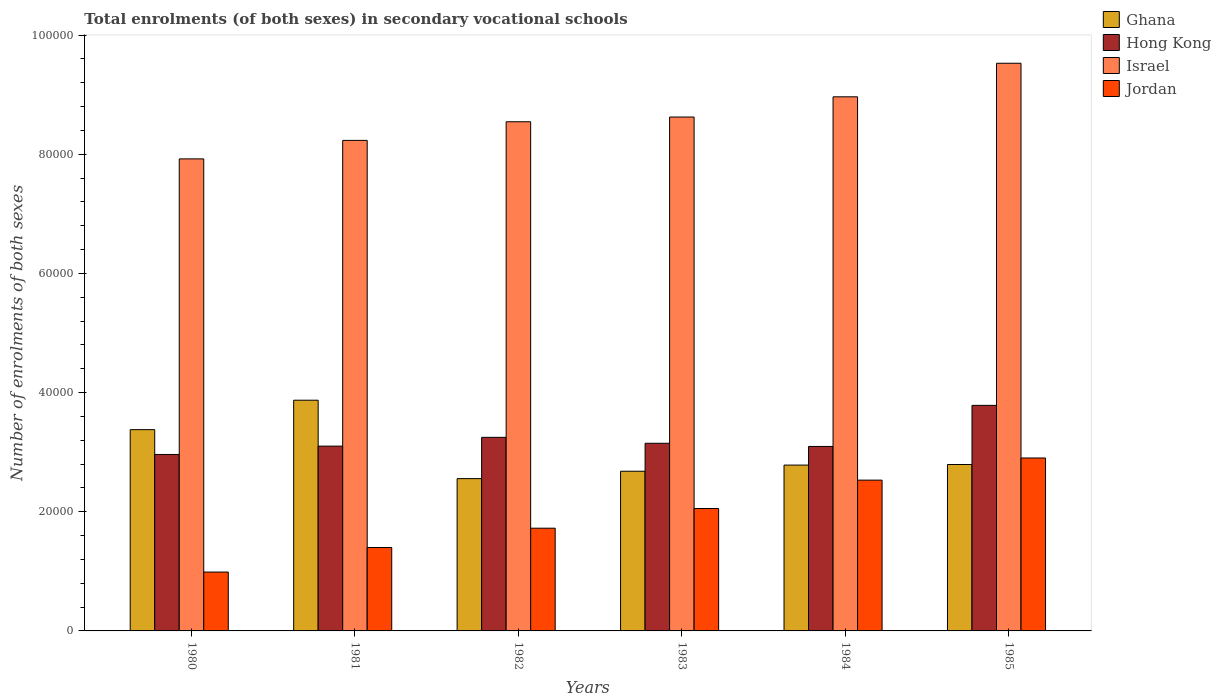How many different coloured bars are there?
Make the answer very short. 4. Are the number of bars per tick equal to the number of legend labels?
Provide a short and direct response. Yes. Are the number of bars on each tick of the X-axis equal?
Offer a terse response. Yes. How many bars are there on the 6th tick from the left?
Your answer should be very brief. 4. In how many cases, is the number of bars for a given year not equal to the number of legend labels?
Your answer should be compact. 0. What is the number of enrolments in secondary schools in Hong Kong in 1984?
Your answer should be compact. 3.10e+04. Across all years, what is the maximum number of enrolments in secondary schools in Ghana?
Offer a very short reply. 3.87e+04. Across all years, what is the minimum number of enrolments in secondary schools in Hong Kong?
Offer a very short reply. 2.96e+04. What is the total number of enrolments in secondary schools in Ghana in the graph?
Keep it short and to the point. 1.81e+05. What is the difference between the number of enrolments in secondary schools in Hong Kong in 1982 and the number of enrolments in secondary schools in Jordan in 1983?
Your response must be concise. 1.19e+04. What is the average number of enrolments in secondary schools in Hong Kong per year?
Your response must be concise. 3.22e+04. In the year 1980, what is the difference between the number of enrolments in secondary schools in Hong Kong and number of enrolments in secondary schools in Jordan?
Your response must be concise. 1.97e+04. What is the ratio of the number of enrolments in secondary schools in Jordan in 1980 to that in 1984?
Keep it short and to the point. 0.39. Is the difference between the number of enrolments in secondary schools in Hong Kong in 1981 and 1982 greater than the difference between the number of enrolments in secondary schools in Jordan in 1981 and 1982?
Provide a succinct answer. Yes. What is the difference between the highest and the second highest number of enrolments in secondary schools in Ghana?
Provide a succinct answer. 4941. What is the difference between the highest and the lowest number of enrolments in secondary schools in Jordan?
Your answer should be very brief. 1.91e+04. In how many years, is the number of enrolments in secondary schools in Hong Kong greater than the average number of enrolments in secondary schools in Hong Kong taken over all years?
Offer a very short reply. 2. Is the sum of the number of enrolments in secondary schools in Ghana in 1980 and 1982 greater than the maximum number of enrolments in secondary schools in Israel across all years?
Make the answer very short. No. What does the 3rd bar from the left in 1984 represents?
Your answer should be very brief. Israel. What does the 1st bar from the right in 1982 represents?
Your answer should be very brief. Jordan. How many bars are there?
Offer a terse response. 24. Are all the bars in the graph horizontal?
Offer a terse response. No. How many years are there in the graph?
Your answer should be very brief. 6. What is the difference between two consecutive major ticks on the Y-axis?
Ensure brevity in your answer.  2.00e+04. Are the values on the major ticks of Y-axis written in scientific E-notation?
Offer a very short reply. No. Does the graph contain grids?
Make the answer very short. No. How many legend labels are there?
Your response must be concise. 4. How are the legend labels stacked?
Provide a short and direct response. Vertical. What is the title of the graph?
Your answer should be very brief. Total enrolments (of both sexes) in secondary vocational schools. Does "Tunisia" appear as one of the legend labels in the graph?
Provide a short and direct response. No. What is the label or title of the Y-axis?
Your answer should be very brief. Number of enrolments of both sexes. What is the Number of enrolments of both sexes of Ghana in 1980?
Make the answer very short. 3.38e+04. What is the Number of enrolments of both sexes in Hong Kong in 1980?
Offer a very short reply. 2.96e+04. What is the Number of enrolments of both sexes of Israel in 1980?
Offer a terse response. 7.92e+04. What is the Number of enrolments of both sexes in Jordan in 1980?
Offer a terse response. 9880. What is the Number of enrolments of both sexes of Ghana in 1981?
Provide a short and direct response. 3.87e+04. What is the Number of enrolments of both sexes in Hong Kong in 1981?
Offer a very short reply. 3.10e+04. What is the Number of enrolments of both sexes in Israel in 1981?
Make the answer very short. 8.23e+04. What is the Number of enrolments of both sexes of Jordan in 1981?
Provide a short and direct response. 1.40e+04. What is the Number of enrolments of both sexes of Ghana in 1982?
Offer a very short reply. 2.56e+04. What is the Number of enrolments of both sexes of Hong Kong in 1982?
Offer a very short reply. 3.25e+04. What is the Number of enrolments of both sexes of Israel in 1982?
Give a very brief answer. 8.55e+04. What is the Number of enrolments of both sexes in Jordan in 1982?
Ensure brevity in your answer.  1.72e+04. What is the Number of enrolments of both sexes in Ghana in 1983?
Offer a very short reply. 2.68e+04. What is the Number of enrolments of both sexes in Hong Kong in 1983?
Your answer should be very brief. 3.15e+04. What is the Number of enrolments of both sexes of Israel in 1983?
Your answer should be very brief. 8.63e+04. What is the Number of enrolments of both sexes in Jordan in 1983?
Offer a very short reply. 2.05e+04. What is the Number of enrolments of both sexes in Ghana in 1984?
Offer a very short reply. 2.78e+04. What is the Number of enrolments of both sexes in Hong Kong in 1984?
Keep it short and to the point. 3.10e+04. What is the Number of enrolments of both sexes in Israel in 1984?
Provide a succinct answer. 8.96e+04. What is the Number of enrolments of both sexes in Jordan in 1984?
Provide a short and direct response. 2.53e+04. What is the Number of enrolments of both sexes in Ghana in 1985?
Your answer should be compact. 2.79e+04. What is the Number of enrolments of both sexes of Hong Kong in 1985?
Your answer should be compact. 3.79e+04. What is the Number of enrolments of both sexes in Israel in 1985?
Keep it short and to the point. 9.53e+04. What is the Number of enrolments of both sexes in Jordan in 1985?
Keep it short and to the point. 2.90e+04. Across all years, what is the maximum Number of enrolments of both sexes of Ghana?
Give a very brief answer. 3.87e+04. Across all years, what is the maximum Number of enrolments of both sexes in Hong Kong?
Your answer should be very brief. 3.79e+04. Across all years, what is the maximum Number of enrolments of both sexes in Israel?
Offer a very short reply. 9.53e+04. Across all years, what is the maximum Number of enrolments of both sexes in Jordan?
Offer a terse response. 2.90e+04. Across all years, what is the minimum Number of enrolments of both sexes of Ghana?
Your answer should be compact. 2.56e+04. Across all years, what is the minimum Number of enrolments of both sexes of Hong Kong?
Ensure brevity in your answer.  2.96e+04. Across all years, what is the minimum Number of enrolments of both sexes in Israel?
Give a very brief answer. 7.92e+04. Across all years, what is the minimum Number of enrolments of both sexes in Jordan?
Provide a succinct answer. 9880. What is the total Number of enrolments of both sexes of Ghana in the graph?
Provide a short and direct response. 1.81e+05. What is the total Number of enrolments of both sexes of Hong Kong in the graph?
Your answer should be compact. 1.93e+05. What is the total Number of enrolments of both sexes of Israel in the graph?
Ensure brevity in your answer.  5.18e+05. What is the total Number of enrolments of both sexes of Jordan in the graph?
Provide a succinct answer. 1.16e+05. What is the difference between the Number of enrolments of both sexes in Ghana in 1980 and that in 1981?
Your response must be concise. -4941. What is the difference between the Number of enrolments of both sexes of Hong Kong in 1980 and that in 1981?
Ensure brevity in your answer.  -1402. What is the difference between the Number of enrolments of both sexes of Israel in 1980 and that in 1981?
Offer a terse response. -3104. What is the difference between the Number of enrolments of both sexes in Jordan in 1980 and that in 1981?
Make the answer very short. -4121. What is the difference between the Number of enrolments of both sexes of Ghana in 1980 and that in 1982?
Your answer should be very brief. 8219. What is the difference between the Number of enrolments of both sexes of Hong Kong in 1980 and that in 1982?
Provide a short and direct response. -2875. What is the difference between the Number of enrolments of both sexes in Israel in 1980 and that in 1982?
Your answer should be compact. -6231. What is the difference between the Number of enrolments of both sexes in Jordan in 1980 and that in 1982?
Your response must be concise. -7362. What is the difference between the Number of enrolments of both sexes of Ghana in 1980 and that in 1983?
Your response must be concise. 6981. What is the difference between the Number of enrolments of both sexes of Hong Kong in 1980 and that in 1983?
Make the answer very short. -1877. What is the difference between the Number of enrolments of both sexes in Israel in 1980 and that in 1983?
Your answer should be compact. -7025. What is the difference between the Number of enrolments of both sexes of Jordan in 1980 and that in 1983?
Your answer should be compact. -1.07e+04. What is the difference between the Number of enrolments of both sexes of Ghana in 1980 and that in 1984?
Offer a terse response. 5948. What is the difference between the Number of enrolments of both sexes in Hong Kong in 1980 and that in 1984?
Give a very brief answer. -1347. What is the difference between the Number of enrolments of both sexes of Israel in 1980 and that in 1984?
Offer a very short reply. -1.04e+04. What is the difference between the Number of enrolments of both sexes in Jordan in 1980 and that in 1984?
Your answer should be compact. -1.54e+04. What is the difference between the Number of enrolments of both sexes in Ghana in 1980 and that in 1985?
Provide a short and direct response. 5850. What is the difference between the Number of enrolments of both sexes in Hong Kong in 1980 and that in 1985?
Keep it short and to the point. -8241. What is the difference between the Number of enrolments of both sexes in Israel in 1980 and that in 1985?
Offer a very short reply. -1.60e+04. What is the difference between the Number of enrolments of both sexes of Jordan in 1980 and that in 1985?
Provide a short and direct response. -1.91e+04. What is the difference between the Number of enrolments of both sexes in Ghana in 1981 and that in 1982?
Ensure brevity in your answer.  1.32e+04. What is the difference between the Number of enrolments of both sexes in Hong Kong in 1981 and that in 1982?
Provide a succinct answer. -1473. What is the difference between the Number of enrolments of both sexes of Israel in 1981 and that in 1982?
Provide a succinct answer. -3127. What is the difference between the Number of enrolments of both sexes of Jordan in 1981 and that in 1982?
Give a very brief answer. -3241. What is the difference between the Number of enrolments of both sexes of Ghana in 1981 and that in 1983?
Keep it short and to the point. 1.19e+04. What is the difference between the Number of enrolments of both sexes in Hong Kong in 1981 and that in 1983?
Ensure brevity in your answer.  -475. What is the difference between the Number of enrolments of both sexes of Israel in 1981 and that in 1983?
Offer a terse response. -3921. What is the difference between the Number of enrolments of both sexes of Jordan in 1981 and that in 1983?
Keep it short and to the point. -6548. What is the difference between the Number of enrolments of both sexes of Ghana in 1981 and that in 1984?
Keep it short and to the point. 1.09e+04. What is the difference between the Number of enrolments of both sexes in Hong Kong in 1981 and that in 1984?
Your answer should be very brief. 55. What is the difference between the Number of enrolments of both sexes of Israel in 1981 and that in 1984?
Give a very brief answer. -7314. What is the difference between the Number of enrolments of both sexes in Jordan in 1981 and that in 1984?
Give a very brief answer. -1.13e+04. What is the difference between the Number of enrolments of both sexes of Ghana in 1981 and that in 1985?
Provide a short and direct response. 1.08e+04. What is the difference between the Number of enrolments of both sexes in Hong Kong in 1981 and that in 1985?
Provide a succinct answer. -6839. What is the difference between the Number of enrolments of both sexes of Israel in 1981 and that in 1985?
Provide a short and direct response. -1.29e+04. What is the difference between the Number of enrolments of both sexes in Jordan in 1981 and that in 1985?
Give a very brief answer. -1.50e+04. What is the difference between the Number of enrolments of both sexes in Ghana in 1982 and that in 1983?
Make the answer very short. -1238. What is the difference between the Number of enrolments of both sexes of Hong Kong in 1982 and that in 1983?
Provide a succinct answer. 998. What is the difference between the Number of enrolments of both sexes in Israel in 1982 and that in 1983?
Give a very brief answer. -794. What is the difference between the Number of enrolments of both sexes in Jordan in 1982 and that in 1983?
Provide a short and direct response. -3307. What is the difference between the Number of enrolments of both sexes in Ghana in 1982 and that in 1984?
Ensure brevity in your answer.  -2271. What is the difference between the Number of enrolments of both sexes of Hong Kong in 1982 and that in 1984?
Offer a terse response. 1528. What is the difference between the Number of enrolments of both sexes in Israel in 1982 and that in 1984?
Make the answer very short. -4187. What is the difference between the Number of enrolments of both sexes of Jordan in 1982 and that in 1984?
Offer a very short reply. -8068. What is the difference between the Number of enrolments of both sexes of Ghana in 1982 and that in 1985?
Make the answer very short. -2369. What is the difference between the Number of enrolments of both sexes in Hong Kong in 1982 and that in 1985?
Provide a succinct answer. -5366. What is the difference between the Number of enrolments of both sexes in Israel in 1982 and that in 1985?
Your answer should be compact. -9819. What is the difference between the Number of enrolments of both sexes in Jordan in 1982 and that in 1985?
Give a very brief answer. -1.18e+04. What is the difference between the Number of enrolments of both sexes in Ghana in 1983 and that in 1984?
Keep it short and to the point. -1033. What is the difference between the Number of enrolments of both sexes of Hong Kong in 1983 and that in 1984?
Make the answer very short. 530. What is the difference between the Number of enrolments of both sexes of Israel in 1983 and that in 1984?
Offer a terse response. -3393. What is the difference between the Number of enrolments of both sexes of Jordan in 1983 and that in 1984?
Provide a succinct answer. -4761. What is the difference between the Number of enrolments of both sexes of Ghana in 1983 and that in 1985?
Offer a very short reply. -1131. What is the difference between the Number of enrolments of both sexes in Hong Kong in 1983 and that in 1985?
Your answer should be compact. -6364. What is the difference between the Number of enrolments of both sexes of Israel in 1983 and that in 1985?
Ensure brevity in your answer.  -9025. What is the difference between the Number of enrolments of both sexes of Jordan in 1983 and that in 1985?
Your answer should be compact. -8477. What is the difference between the Number of enrolments of both sexes of Ghana in 1984 and that in 1985?
Offer a terse response. -98. What is the difference between the Number of enrolments of both sexes of Hong Kong in 1984 and that in 1985?
Offer a very short reply. -6894. What is the difference between the Number of enrolments of both sexes of Israel in 1984 and that in 1985?
Offer a terse response. -5632. What is the difference between the Number of enrolments of both sexes in Jordan in 1984 and that in 1985?
Your answer should be very brief. -3716. What is the difference between the Number of enrolments of both sexes of Ghana in 1980 and the Number of enrolments of both sexes of Hong Kong in 1981?
Provide a succinct answer. 2763. What is the difference between the Number of enrolments of both sexes of Ghana in 1980 and the Number of enrolments of both sexes of Israel in 1981?
Your response must be concise. -4.86e+04. What is the difference between the Number of enrolments of both sexes of Ghana in 1980 and the Number of enrolments of both sexes of Jordan in 1981?
Provide a short and direct response. 1.98e+04. What is the difference between the Number of enrolments of both sexes in Hong Kong in 1980 and the Number of enrolments of both sexes in Israel in 1981?
Provide a succinct answer. -5.27e+04. What is the difference between the Number of enrolments of both sexes in Hong Kong in 1980 and the Number of enrolments of both sexes in Jordan in 1981?
Ensure brevity in your answer.  1.56e+04. What is the difference between the Number of enrolments of both sexes in Israel in 1980 and the Number of enrolments of both sexes in Jordan in 1981?
Make the answer very short. 6.52e+04. What is the difference between the Number of enrolments of both sexes of Ghana in 1980 and the Number of enrolments of both sexes of Hong Kong in 1982?
Keep it short and to the point. 1290. What is the difference between the Number of enrolments of both sexes in Ghana in 1980 and the Number of enrolments of both sexes in Israel in 1982?
Ensure brevity in your answer.  -5.17e+04. What is the difference between the Number of enrolments of both sexes in Ghana in 1980 and the Number of enrolments of both sexes in Jordan in 1982?
Ensure brevity in your answer.  1.65e+04. What is the difference between the Number of enrolments of both sexes in Hong Kong in 1980 and the Number of enrolments of both sexes in Israel in 1982?
Give a very brief answer. -5.58e+04. What is the difference between the Number of enrolments of both sexes of Hong Kong in 1980 and the Number of enrolments of both sexes of Jordan in 1982?
Provide a succinct answer. 1.24e+04. What is the difference between the Number of enrolments of both sexes in Israel in 1980 and the Number of enrolments of both sexes in Jordan in 1982?
Your answer should be very brief. 6.20e+04. What is the difference between the Number of enrolments of both sexes in Ghana in 1980 and the Number of enrolments of both sexes in Hong Kong in 1983?
Make the answer very short. 2288. What is the difference between the Number of enrolments of both sexes in Ghana in 1980 and the Number of enrolments of both sexes in Israel in 1983?
Ensure brevity in your answer.  -5.25e+04. What is the difference between the Number of enrolments of both sexes in Ghana in 1980 and the Number of enrolments of both sexes in Jordan in 1983?
Your response must be concise. 1.32e+04. What is the difference between the Number of enrolments of both sexes of Hong Kong in 1980 and the Number of enrolments of both sexes of Israel in 1983?
Offer a terse response. -5.66e+04. What is the difference between the Number of enrolments of both sexes in Hong Kong in 1980 and the Number of enrolments of both sexes in Jordan in 1983?
Your answer should be compact. 9068. What is the difference between the Number of enrolments of both sexes of Israel in 1980 and the Number of enrolments of both sexes of Jordan in 1983?
Give a very brief answer. 5.87e+04. What is the difference between the Number of enrolments of both sexes in Ghana in 1980 and the Number of enrolments of both sexes in Hong Kong in 1984?
Ensure brevity in your answer.  2818. What is the difference between the Number of enrolments of both sexes of Ghana in 1980 and the Number of enrolments of both sexes of Israel in 1984?
Make the answer very short. -5.59e+04. What is the difference between the Number of enrolments of both sexes in Ghana in 1980 and the Number of enrolments of both sexes in Jordan in 1984?
Provide a succinct answer. 8472. What is the difference between the Number of enrolments of both sexes of Hong Kong in 1980 and the Number of enrolments of both sexes of Israel in 1984?
Your response must be concise. -6.00e+04. What is the difference between the Number of enrolments of both sexes of Hong Kong in 1980 and the Number of enrolments of both sexes of Jordan in 1984?
Provide a succinct answer. 4307. What is the difference between the Number of enrolments of both sexes of Israel in 1980 and the Number of enrolments of both sexes of Jordan in 1984?
Your answer should be very brief. 5.39e+04. What is the difference between the Number of enrolments of both sexes of Ghana in 1980 and the Number of enrolments of both sexes of Hong Kong in 1985?
Keep it short and to the point. -4076. What is the difference between the Number of enrolments of both sexes of Ghana in 1980 and the Number of enrolments of both sexes of Israel in 1985?
Offer a terse response. -6.15e+04. What is the difference between the Number of enrolments of both sexes of Ghana in 1980 and the Number of enrolments of both sexes of Jordan in 1985?
Ensure brevity in your answer.  4756. What is the difference between the Number of enrolments of both sexes of Hong Kong in 1980 and the Number of enrolments of both sexes of Israel in 1985?
Keep it short and to the point. -6.57e+04. What is the difference between the Number of enrolments of both sexes in Hong Kong in 1980 and the Number of enrolments of both sexes in Jordan in 1985?
Offer a terse response. 591. What is the difference between the Number of enrolments of both sexes of Israel in 1980 and the Number of enrolments of both sexes of Jordan in 1985?
Offer a very short reply. 5.02e+04. What is the difference between the Number of enrolments of both sexes of Ghana in 1981 and the Number of enrolments of both sexes of Hong Kong in 1982?
Provide a short and direct response. 6231. What is the difference between the Number of enrolments of both sexes of Ghana in 1981 and the Number of enrolments of both sexes of Israel in 1982?
Your answer should be very brief. -4.67e+04. What is the difference between the Number of enrolments of both sexes of Ghana in 1981 and the Number of enrolments of both sexes of Jordan in 1982?
Offer a very short reply. 2.15e+04. What is the difference between the Number of enrolments of both sexes of Hong Kong in 1981 and the Number of enrolments of both sexes of Israel in 1982?
Ensure brevity in your answer.  -5.44e+04. What is the difference between the Number of enrolments of both sexes in Hong Kong in 1981 and the Number of enrolments of both sexes in Jordan in 1982?
Keep it short and to the point. 1.38e+04. What is the difference between the Number of enrolments of both sexes of Israel in 1981 and the Number of enrolments of both sexes of Jordan in 1982?
Offer a very short reply. 6.51e+04. What is the difference between the Number of enrolments of both sexes of Ghana in 1981 and the Number of enrolments of both sexes of Hong Kong in 1983?
Your response must be concise. 7229. What is the difference between the Number of enrolments of both sexes in Ghana in 1981 and the Number of enrolments of both sexes in Israel in 1983?
Your response must be concise. -4.75e+04. What is the difference between the Number of enrolments of both sexes in Ghana in 1981 and the Number of enrolments of both sexes in Jordan in 1983?
Give a very brief answer. 1.82e+04. What is the difference between the Number of enrolments of both sexes in Hong Kong in 1981 and the Number of enrolments of both sexes in Israel in 1983?
Offer a terse response. -5.52e+04. What is the difference between the Number of enrolments of both sexes of Hong Kong in 1981 and the Number of enrolments of both sexes of Jordan in 1983?
Your response must be concise. 1.05e+04. What is the difference between the Number of enrolments of both sexes of Israel in 1981 and the Number of enrolments of both sexes of Jordan in 1983?
Your answer should be very brief. 6.18e+04. What is the difference between the Number of enrolments of both sexes of Ghana in 1981 and the Number of enrolments of both sexes of Hong Kong in 1984?
Your answer should be very brief. 7759. What is the difference between the Number of enrolments of both sexes of Ghana in 1981 and the Number of enrolments of both sexes of Israel in 1984?
Your answer should be very brief. -5.09e+04. What is the difference between the Number of enrolments of both sexes of Ghana in 1981 and the Number of enrolments of both sexes of Jordan in 1984?
Keep it short and to the point. 1.34e+04. What is the difference between the Number of enrolments of both sexes of Hong Kong in 1981 and the Number of enrolments of both sexes of Israel in 1984?
Provide a short and direct response. -5.86e+04. What is the difference between the Number of enrolments of both sexes in Hong Kong in 1981 and the Number of enrolments of both sexes in Jordan in 1984?
Keep it short and to the point. 5709. What is the difference between the Number of enrolments of both sexes in Israel in 1981 and the Number of enrolments of both sexes in Jordan in 1984?
Provide a short and direct response. 5.70e+04. What is the difference between the Number of enrolments of both sexes in Ghana in 1981 and the Number of enrolments of both sexes in Hong Kong in 1985?
Give a very brief answer. 865. What is the difference between the Number of enrolments of both sexes in Ghana in 1981 and the Number of enrolments of both sexes in Israel in 1985?
Provide a short and direct response. -5.66e+04. What is the difference between the Number of enrolments of both sexes in Ghana in 1981 and the Number of enrolments of both sexes in Jordan in 1985?
Give a very brief answer. 9697. What is the difference between the Number of enrolments of both sexes in Hong Kong in 1981 and the Number of enrolments of both sexes in Israel in 1985?
Make the answer very short. -6.43e+04. What is the difference between the Number of enrolments of both sexes of Hong Kong in 1981 and the Number of enrolments of both sexes of Jordan in 1985?
Provide a succinct answer. 1993. What is the difference between the Number of enrolments of both sexes in Israel in 1981 and the Number of enrolments of both sexes in Jordan in 1985?
Your response must be concise. 5.33e+04. What is the difference between the Number of enrolments of both sexes of Ghana in 1982 and the Number of enrolments of both sexes of Hong Kong in 1983?
Make the answer very short. -5931. What is the difference between the Number of enrolments of both sexes in Ghana in 1982 and the Number of enrolments of both sexes in Israel in 1983?
Give a very brief answer. -6.07e+04. What is the difference between the Number of enrolments of both sexes of Ghana in 1982 and the Number of enrolments of both sexes of Jordan in 1983?
Make the answer very short. 5014. What is the difference between the Number of enrolments of both sexes in Hong Kong in 1982 and the Number of enrolments of both sexes in Israel in 1983?
Keep it short and to the point. -5.38e+04. What is the difference between the Number of enrolments of both sexes in Hong Kong in 1982 and the Number of enrolments of both sexes in Jordan in 1983?
Offer a terse response. 1.19e+04. What is the difference between the Number of enrolments of both sexes of Israel in 1982 and the Number of enrolments of both sexes of Jordan in 1983?
Ensure brevity in your answer.  6.49e+04. What is the difference between the Number of enrolments of both sexes of Ghana in 1982 and the Number of enrolments of both sexes of Hong Kong in 1984?
Your answer should be very brief. -5401. What is the difference between the Number of enrolments of both sexes in Ghana in 1982 and the Number of enrolments of both sexes in Israel in 1984?
Your answer should be compact. -6.41e+04. What is the difference between the Number of enrolments of both sexes of Ghana in 1982 and the Number of enrolments of both sexes of Jordan in 1984?
Provide a short and direct response. 253. What is the difference between the Number of enrolments of both sexes in Hong Kong in 1982 and the Number of enrolments of both sexes in Israel in 1984?
Ensure brevity in your answer.  -5.72e+04. What is the difference between the Number of enrolments of both sexes in Hong Kong in 1982 and the Number of enrolments of both sexes in Jordan in 1984?
Give a very brief answer. 7182. What is the difference between the Number of enrolments of both sexes in Israel in 1982 and the Number of enrolments of both sexes in Jordan in 1984?
Give a very brief answer. 6.01e+04. What is the difference between the Number of enrolments of both sexes in Ghana in 1982 and the Number of enrolments of both sexes in Hong Kong in 1985?
Ensure brevity in your answer.  -1.23e+04. What is the difference between the Number of enrolments of both sexes in Ghana in 1982 and the Number of enrolments of both sexes in Israel in 1985?
Offer a terse response. -6.97e+04. What is the difference between the Number of enrolments of both sexes in Ghana in 1982 and the Number of enrolments of both sexes in Jordan in 1985?
Offer a very short reply. -3463. What is the difference between the Number of enrolments of both sexes in Hong Kong in 1982 and the Number of enrolments of both sexes in Israel in 1985?
Your response must be concise. -6.28e+04. What is the difference between the Number of enrolments of both sexes of Hong Kong in 1982 and the Number of enrolments of both sexes of Jordan in 1985?
Your response must be concise. 3466. What is the difference between the Number of enrolments of both sexes in Israel in 1982 and the Number of enrolments of both sexes in Jordan in 1985?
Keep it short and to the point. 5.64e+04. What is the difference between the Number of enrolments of both sexes in Ghana in 1983 and the Number of enrolments of both sexes in Hong Kong in 1984?
Ensure brevity in your answer.  -4163. What is the difference between the Number of enrolments of both sexes of Ghana in 1983 and the Number of enrolments of both sexes of Israel in 1984?
Your answer should be very brief. -6.28e+04. What is the difference between the Number of enrolments of both sexes of Ghana in 1983 and the Number of enrolments of both sexes of Jordan in 1984?
Offer a very short reply. 1491. What is the difference between the Number of enrolments of both sexes in Hong Kong in 1983 and the Number of enrolments of both sexes in Israel in 1984?
Your answer should be very brief. -5.82e+04. What is the difference between the Number of enrolments of both sexes of Hong Kong in 1983 and the Number of enrolments of both sexes of Jordan in 1984?
Provide a succinct answer. 6184. What is the difference between the Number of enrolments of both sexes in Israel in 1983 and the Number of enrolments of both sexes in Jordan in 1984?
Provide a short and direct response. 6.09e+04. What is the difference between the Number of enrolments of both sexes in Ghana in 1983 and the Number of enrolments of both sexes in Hong Kong in 1985?
Provide a succinct answer. -1.11e+04. What is the difference between the Number of enrolments of both sexes in Ghana in 1983 and the Number of enrolments of both sexes in Israel in 1985?
Provide a succinct answer. -6.85e+04. What is the difference between the Number of enrolments of both sexes of Ghana in 1983 and the Number of enrolments of both sexes of Jordan in 1985?
Ensure brevity in your answer.  -2225. What is the difference between the Number of enrolments of both sexes of Hong Kong in 1983 and the Number of enrolments of both sexes of Israel in 1985?
Provide a succinct answer. -6.38e+04. What is the difference between the Number of enrolments of both sexes in Hong Kong in 1983 and the Number of enrolments of both sexes in Jordan in 1985?
Offer a very short reply. 2468. What is the difference between the Number of enrolments of both sexes in Israel in 1983 and the Number of enrolments of both sexes in Jordan in 1985?
Your answer should be compact. 5.72e+04. What is the difference between the Number of enrolments of both sexes in Ghana in 1984 and the Number of enrolments of both sexes in Hong Kong in 1985?
Your answer should be very brief. -1.00e+04. What is the difference between the Number of enrolments of both sexes of Ghana in 1984 and the Number of enrolments of both sexes of Israel in 1985?
Offer a very short reply. -6.74e+04. What is the difference between the Number of enrolments of both sexes of Ghana in 1984 and the Number of enrolments of both sexes of Jordan in 1985?
Make the answer very short. -1192. What is the difference between the Number of enrolments of both sexes in Hong Kong in 1984 and the Number of enrolments of both sexes in Israel in 1985?
Provide a succinct answer. -6.43e+04. What is the difference between the Number of enrolments of both sexes of Hong Kong in 1984 and the Number of enrolments of both sexes of Jordan in 1985?
Your answer should be very brief. 1938. What is the difference between the Number of enrolments of both sexes of Israel in 1984 and the Number of enrolments of both sexes of Jordan in 1985?
Provide a succinct answer. 6.06e+04. What is the average Number of enrolments of both sexes of Ghana per year?
Provide a short and direct response. 3.01e+04. What is the average Number of enrolments of both sexes in Hong Kong per year?
Offer a terse response. 3.22e+04. What is the average Number of enrolments of both sexes in Israel per year?
Give a very brief answer. 8.64e+04. What is the average Number of enrolments of both sexes in Jordan per year?
Keep it short and to the point. 1.93e+04. In the year 1980, what is the difference between the Number of enrolments of both sexes of Ghana and Number of enrolments of both sexes of Hong Kong?
Provide a succinct answer. 4165. In the year 1980, what is the difference between the Number of enrolments of both sexes of Ghana and Number of enrolments of both sexes of Israel?
Offer a terse response. -4.54e+04. In the year 1980, what is the difference between the Number of enrolments of both sexes of Ghana and Number of enrolments of both sexes of Jordan?
Your answer should be compact. 2.39e+04. In the year 1980, what is the difference between the Number of enrolments of both sexes of Hong Kong and Number of enrolments of both sexes of Israel?
Your response must be concise. -4.96e+04. In the year 1980, what is the difference between the Number of enrolments of both sexes in Hong Kong and Number of enrolments of both sexes in Jordan?
Ensure brevity in your answer.  1.97e+04. In the year 1980, what is the difference between the Number of enrolments of both sexes in Israel and Number of enrolments of both sexes in Jordan?
Your answer should be very brief. 6.93e+04. In the year 1981, what is the difference between the Number of enrolments of both sexes in Ghana and Number of enrolments of both sexes in Hong Kong?
Your answer should be compact. 7704. In the year 1981, what is the difference between the Number of enrolments of both sexes in Ghana and Number of enrolments of both sexes in Israel?
Keep it short and to the point. -4.36e+04. In the year 1981, what is the difference between the Number of enrolments of both sexes of Ghana and Number of enrolments of both sexes of Jordan?
Your answer should be compact. 2.47e+04. In the year 1981, what is the difference between the Number of enrolments of both sexes in Hong Kong and Number of enrolments of both sexes in Israel?
Keep it short and to the point. -5.13e+04. In the year 1981, what is the difference between the Number of enrolments of both sexes in Hong Kong and Number of enrolments of both sexes in Jordan?
Offer a very short reply. 1.70e+04. In the year 1981, what is the difference between the Number of enrolments of both sexes of Israel and Number of enrolments of both sexes of Jordan?
Your answer should be compact. 6.83e+04. In the year 1982, what is the difference between the Number of enrolments of both sexes of Ghana and Number of enrolments of both sexes of Hong Kong?
Your answer should be very brief. -6929. In the year 1982, what is the difference between the Number of enrolments of both sexes in Ghana and Number of enrolments of both sexes in Israel?
Your response must be concise. -5.99e+04. In the year 1982, what is the difference between the Number of enrolments of both sexes in Ghana and Number of enrolments of both sexes in Jordan?
Give a very brief answer. 8321. In the year 1982, what is the difference between the Number of enrolments of both sexes in Hong Kong and Number of enrolments of both sexes in Israel?
Make the answer very short. -5.30e+04. In the year 1982, what is the difference between the Number of enrolments of both sexes in Hong Kong and Number of enrolments of both sexes in Jordan?
Ensure brevity in your answer.  1.52e+04. In the year 1982, what is the difference between the Number of enrolments of both sexes of Israel and Number of enrolments of both sexes of Jordan?
Ensure brevity in your answer.  6.82e+04. In the year 1983, what is the difference between the Number of enrolments of both sexes of Ghana and Number of enrolments of both sexes of Hong Kong?
Offer a very short reply. -4693. In the year 1983, what is the difference between the Number of enrolments of both sexes in Ghana and Number of enrolments of both sexes in Israel?
Give a very brief answer. -5.95e+04. In the year 1983, what is the difference between the Number of enrolments of both sexes in Ghana and Number of enrolments of both sexes in Jordan?
Make the answer very short. 6252. In the year 1983, what is the difference between the Number of enrolments of both sexes of Hong Kong and Number of enrolments of both sexes of Israel?
Provide a succinct answer. -5.48e+04. In the year 1983, what is the difference between the Number of enrolments of both sexes of Hong Kong and Number of enrolments of both sexes of Jordan?
Offer a terse response. 1.09e+04. In the year 1983, what is the difference between the Number of enrolments of both sexes in Israel and Number of enrolments of both sexes in Jordan?
Give a very brief answer. 6.57e+04. In the year 1984, what is the difference between the Number of enrolments of both sexes of Ghana and Number of enrolments of both sexes of Hong Kong?
Provide a succinct answer. -3130. In the year 1984, what is the difference between the Number of enrolments of both sexes in Ghana and Number of enrolments of both sexes in Israel?
Provide a succinct answer. -6.18e+04. In the year 1984, what is the difference between the Number of enrolments of both sexes of Ghana and Number of enrolments of both sexes of Jordan?
Provide a short and direct response. 2524. In the year 1984, what is the difference between the Number of enrolments of both sexes in Hong Kong and Number of enrolments of both sexes in Israel?
Make the answer very short. -5.87e+04. In the year 1984, what is the difference between the Number of enrolments of both sexes in Hong Kong and Number of enrolments of both sexes in Jordan?
Your answer should be very brief. 5654. In the year 1984, what is the difference between the Number of enrolments of both sexes of Israel and Number of enrolments of both sexes of Jordan?
Make the answer very short. 6.43e+04. In the year 1985, what is the difference between the Number of enrolments of both sexes of Ghana and Number of enrolments of both sexes of Hong Kong?
Your response must be concise. -9926. In the year 1985, what is the difference between the Number of enrolments of both sexes in Ghana and Number of enrolments of both sexes in Israel?
Ensure brevity in your answer.  -6.73e+04. In the year 1985, what is the difference between the Number of enrolments of both sexes in Ghana and Number of enrolments of both sexes in Jordan?
Provide a short and direct response. -1094. In the year 1985, what is the difference between the Number of enrolments of both sexes of Hong Kong and Number of enrolments of both sexes of Israel?
Give a very brief answer. -5.74e+04. In the year 1985, what is the difference between the Number of enrolments of both sexes of Hong Kong and Number of enrolments of both sexes of Jordan?
Offer a terse response. 8832. In the year 1985, what is the difference between the Number of enrolments of both sexes of Israel and Number of enrolments of both sexes of Jordan?
Make the answer very short. 6.63e+04. What is the ratio of the Number of enrolments of both sexes in Ghana in 1980 to that in 1981?
Offer a very short reply. 0.87. What is the ratio of the Number of enrolments of both sexes in Hong Kong in 1980 to that in 1981?
Your answer should be very brief. 0.95. What is the ratio of the Number of enrolments of both sexes in Israel in 1980 to that in 1981?
Ensure brevity in your answer.  0.96. What is the ratio of the Number of enrolments of both sexes of Jordan in 1980 to that in 1981?
Give a very brief answer. 0.71. What is the ratio of the Number of enrolments of both sexes in Ghana in 1980 to that in 1982?
Ensure brevity in your answer.  1.32. What is the ratio of the Number of enrolments of both sexes of Hong Kong in 1980 to that in 1982?
Your response must be concise. 0.91. What is the ratio of the Number of enrolments of both sexes in Israel in 1980 to that in 1982?
Your answer should be very brief. 0.93. What is the ratio of the Number of enrolments of both sexes in Jordan in 1980 to that in 1982?
Make the answer very short. 0.57. What is the ratio of the Number of enrolments of both sexes of Ghana in 1980 to that in 1983?
Provide a short and direct response. 1.26. What is the ratio of the Number of enrolments of both sexes of Hong Kong in 1980 to that in 1983?
Provide a short and direct response. 0.94. What is the ratio of the Number of enrolments of both sexes of Israel in 1980 to that in 1983?
Your answer should be compact. 0.92. What is the ratio of the Number of enrolments of both sexes of Jordan in 1980 to that in 1983?
Offer a very short reply. 0.48. What is the ratio of the Number of enrolments of both sexes in Ghana in 1980 to that in 1984?
Your answer should be very brief. 1.21. What is the ratio of the Number of enrolments of both sexes of Hong Kong in 1980 to that in 1984?
Your answer should be very brief. 0.96. What is the ratio of the Number of enrolments of both sexes of Israel in 1980 to that in 1984?
Provide a short and direct response. 0.88. What is the ratio of the Number of enrolments of both sexes of Jordan in 1980 to that in 1984?
Offer a terse response. 0.39. What is the ratio of the Number of enrolments of both sexes of Ghana in 1980 to that in 1985?
Offer a very short reply. 1.21. What is the ratio of the Number of enrolments of both sexes in Hong Kong in 1980 to that in 1985?
Offer a terse response. 0.78. What is the ratio of the Number of enrolments of both sexes of Israel in 1980 to that in 1985?
Make the answer very short. 0.83. What is the ratio of the Number of enrolments of both sexes in Jordan in 1980 to that in 1985?
Your answer should be compact. 0.34. What is the ratio of the Number of enrolments of both sexes of Ghana in 1981 to that in 1982?
Provide a short and direct response. 1.51. What is the ratio of the Number of enrolments of both sexes in Hong Kong in 1981 to that in 1982?
Give a very brief answer. 0.95. What is the ratio of the Number of enrolments of both sexes in Israel in 1981 to that in 1982?
Provide a short and direct response. 0.96. What is the ratio of the Number of enrolments of both sexes of Jordan in 1981 to that in 1982?
Your answer should be compact. 0.81. What is the ratio of the Number of enrolments of both sexes in Ghana in 1981 to that in 1983?
Your answer should be compact. 1.44. What is the ratio of the Number of enrolments of both sexes in Hong Kong in 1981 to that in 1983?
Your answer should be very brief. 0.98. What is the ratio of the Number of enrolments of both sexes of Israel in 1981 to that in 1983?
Provide a short and direct response. 0.95. What is the ratio of the Number of enrolments of both sexes of Jordan in 1981 to that in 1983?
Ensure brevity in your answer.  0.68. What is the ratio of the Number of enrolments of both sexes in Ghana in 1981 to that in 1984?
Ensure brevity in your answer.  1.39. What is the ratio of the Number of enrolments of both sexes of Hong Kong in 1981 to that in 1984?
Offer a terse response. 1. What is the ratio of the Number of enrolments of both sexes of Israel in 1981 to that in 1984?
Keep it short and to the point. 0.92. What is the ratio of the Number of enrolments of both sexes in Jordan in 1981 to that in 1984?
Your answer should be compact. 0.55. What is the ratio of the Number of enrolments of both sexes of Ghana in 1981 to that in 1985?
Your answer should be very brief. 1.39. What is the ratio of the Number of enrolments of both sexes in Hong Kong in 1981 to that in 1985?
Your answer should be compact. 0.82. What is the ratio of the Number of enrolments of both sexes of Israel in 1981 to that in 1985?
Provide a short and direct response. 0.86. What is the ratio of the Number of enrolments of both sexes in Jordan in 1981 to that in 1985?
Provide a short and direct response. 0.48. What is the ratio of the Number of enrolments of both sexes of Ghana in 1982 to that in 1983?
Keep it short and to the point. 0.95. What is the ratio of the Number of enrolments of both sexes of Hong Kong in 1982 to that in 1983?
Your answer should be very brief. 1.03. What is the ratio of the Number of enrolments of both sexes of Jordan in 1982 to that in 1983?
Make the answer very short. 0.84. What is the ratio of the Number of enrolments of both sexes of Ghana in 1982 to that in 1984?
Offer a very short reply. 0.92. What is the ratio of the Number of enrolments of both sexes of Hong Kong in 1982 to that in 1984?
Offer a terse response. 1.05. What is the ratio of the Number of enrolments of both sexes in Israel in 1982 to that in 1984?
Give a very brief answer. 0.95. What is the ratio of the Number of enrolments of both sexes in Jordan in 1982 to that in 1984?
Offer a terse response. 0.68. What is the ratio of the Number of enrolments of both sexes in Ghana in 1982 to that in 1985?
Ensure brevity in your answer.  0.92. What is the ratio of the Number of enrolments of both sexes of Hong Kong in 1982 to that in 1985?
Offer a very short reply. 0.86. What is the ratio of the Number of enrolments of both sexes in Israel in 1982 to that in 1985?
Your answer should be very brief. 0.9. What is the ratio of the Number of enrolments of both sexes in Jordan in 1982 to that in 1985?
Give a very brief answer. 0.59. What is the ratio of the Number of enrolments of both sexes in Ghana in 1983 to that in 1984?
Your response must be concise. 0.96. What is the ratio of the Number of enrolments of both sexes in Hong Kong in 1983 to that in 1984?
Provide a succinct answer. 1.02. What is the ratio of the Number of enrolments of both sexes of Israel in 1983 to that in 1984?
Provide a succinct answer. 0.96. What is the ratio of the Number of enrolments of both sexes in Jordan in 1983 to that in 1984?
Your answer should be compact. 0.81. What is the ratio of the Number of enrolments of both sexes in Ghana in 1983 to that in 1985?
Offer a terse response. 0.96. What is the ratio of the Number of enrolments of both sexes in Hong Kong in 1983 to that in 1985?
Offer a terse response. 0.83. What is the ratio of the Number of enrolments of both sexes in Israel in 1983 to that in 1985?
Provide a succinct answer. 0.91. What is the ratio of the Number of enrolments of both sexes of Jordan in 1983 to that in 1985?
Your answer should be compact. 0.71. What is the ratio of the Number of enrolments of both sexes in Ghana in 1984 to that in 1985?
Offer a terse response. 1. What is the ratio of the Number of enrolments of both sexes in Hong Kong in 1984 to that in 1985?
Provide a succinct answer. 0.82. What is the ratio of the Number of enrolments of both sexes of Israel in 1984 to that in 1985?
Make the answer very short. 0.94. What is the ratio of the Number of enrolments of both sexes in Jordan in 1984 to that in 1985?
Provide a short and direct response. 0.87. What is the difference between the highest and the second highest Number of enrolments of both sexes of Ghana?
Make the answer very short. 4941. What is the difference between the highest and the second highest Number of enrolments of both sexes in Hong Kong?
Provide a succinct answer. 5366. What is the difference between the highest and the second highest Number of enrolments of both sexes of Israel?
Your response must be concise. 5632. What is the difference between the highest and the second highest Number of enrolments of both sexes of Jordan?
Your answer should be compact. 3716. What is the difference between the highest and the lowest Number of enrolments of both sexes in Ghana?
Your answer should be compact. 1.32e+04. What is the difference between the highest and the lowest Number of enrolments of both sexes of Hong Kong?
Provide a succinct answer. 8241. What is the difference between the highest and the lowest Number of enrolments of both sexes in Israel?
Provide a succinct answer. 1.60e+04. What is the difference between the highest and the lowest Number of enrolments of both sexes in Jordan?
Make the answer very short. 1.91e+04. 